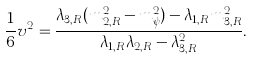Convert formula to latex. <formula><loc_0><loc_0><loc_500><loc_500>\frac { 1 } { 6 } v ^ { 2 } = \frac { \lambda _ { 3 , R } ( m _ { 2 , R } ^ { 2 } - m _ { \psi } ^ { 2 } ) - \lambda _ { 1 , R } m _ { 3 , R } ^ { 2 } } { \lambda _ { 1 , R } \lambda _ { 2 , R } - \lambda _ { 3 , R } ^ { 2 } } .</formula> 